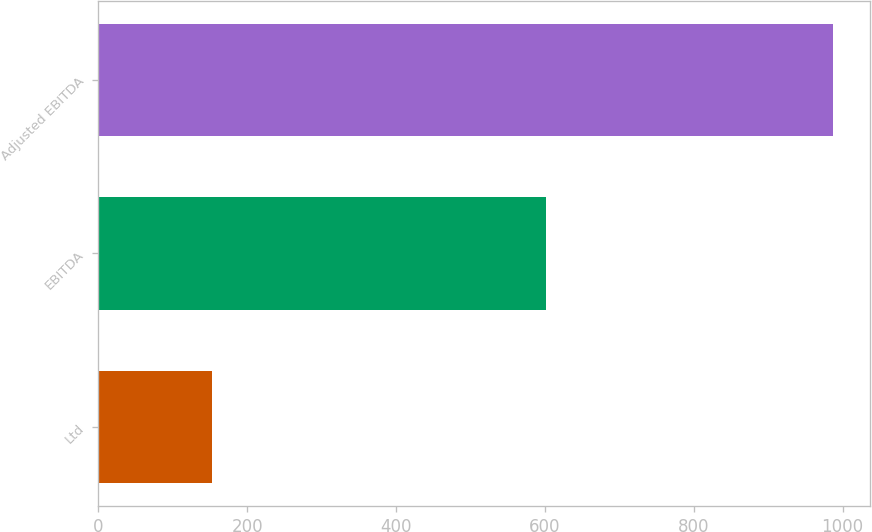<chart> <loc_0><loc_0><loc_500><loc_500><bar_chart><fcel>Ltd<fcel>EBITDA<fcel>Adjusted EBITDA<nl><fcel>152.8<fcel>601.5<fcel>987.7<nl></chart> 